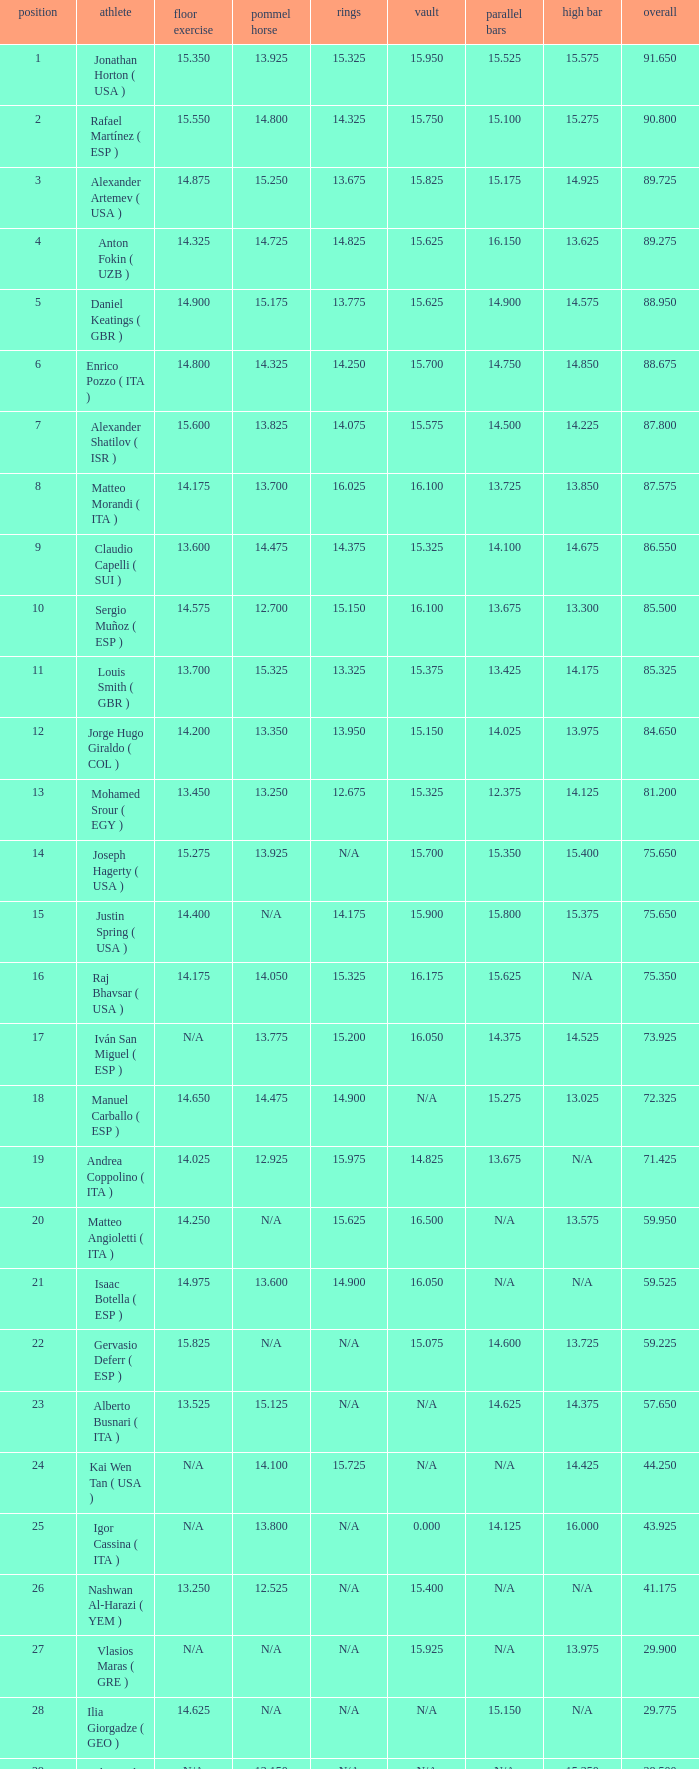200, what is the number for the parallel bars? 14.025. 